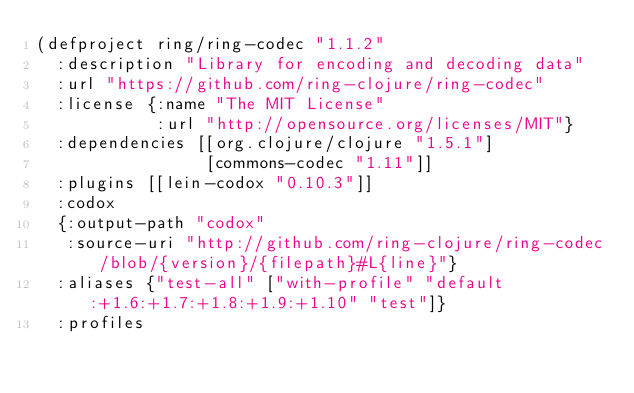<code> <loc_0><loc_0><loc_500><loc_500><_Clojure_>(defproject ring/ring-codec "1.1.2"
  :description "Library for encoding and decoding data"
  :url "https://github.com/ring-clojure/ring-codec"
  :license {:name "The MIT License"
            :url "http://opensource.org/licenses/MIT"}
  :dependencies [[org.clojure/clojure "1.5.1"]
                 [commons-codec "1.11"]]
  :plugins [[lein-codox "0.10.3"]]
  :codox
  {:output-path "codox"
   :source-uri "http://github.com/ring-clojure/ring-codec/blob/{version}/{filepath}#L{line}"}
  :aliases {"test-all" ["with-profile" "default:+1.6:+1.7:+1.8:+1.9:+1.10" "test"]}
  :profiles</code> 